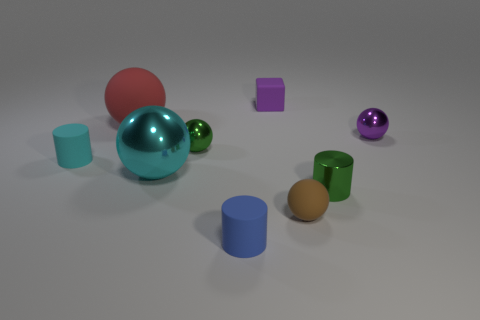What material is the ball that is the same color as the metal cylinder?
Ensure brevity in your answer.  Metal. How many brown things are the same material as the cyan cylinder?
Provide a succinct answer. 1. What number of objects are tiny objects that are to the right of the small green metal sphere or metallic objects in front of the tiny green metallic sphere?
Provide a short and direct response. 6. Are there more large shiny balls behind the big red sphere than purple balls that are to the left of the blue cylinder?
Your answer should be very brief. No. There is a rubber sphere that is left of the blue matte thing; what color is it?
Make the answer very short. Red. Are there any green metal objects that have the same shape as the big rubber object?
Your answer should be very brief. Yes. What number of cyan objects are either tiny rubber objects or shiny cylinders?
Provide a succinct answer. 1. Is there a cylinder of the same size as the red rubber ball?
Provide a succinct answer. No. How many small yellow matte spheres are there?
Ensure brevity in your answer.  0. How many large objects are either blue rubber cylinders or blue metallic cubes?
Provide a short and direct response. 0. 